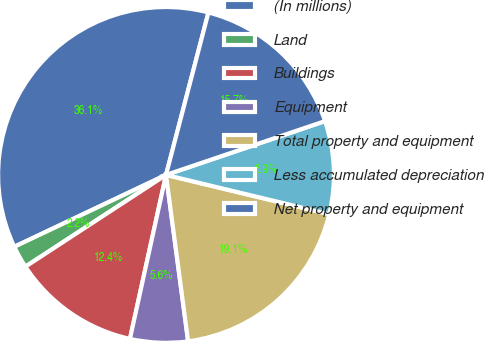Convert chart. <chart><loc_0><loc_0><loc_500><loc_500><pie_chart><fcel>(In millions)<fcel>Land<fcel>Buildings<fcel>Equipment<fcel>Total property and equipment<fcel>Less accumulated depreciation<fcel>Net property and equipment<nl><fcel>36.11%<fcel>2.16%<fcel>12.35%<fcel>5.55%<fcel>19.14%<fcel>8.95%<fcel>15.74%<nl></chart> 